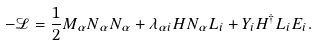<formula> <loc_0><loc_0><loc_500><loc_500>- \mathcal { L } = \frac { 1 } { 2 } M _ { \alpha } N _ { \alpha } N _ { \alpha } + \lambda _ { \alpha i } H N _ { \alpha } L _ { i } + Y _ { i } H ^ { \dagger } L _ { i } E _ { i } .</formula> 